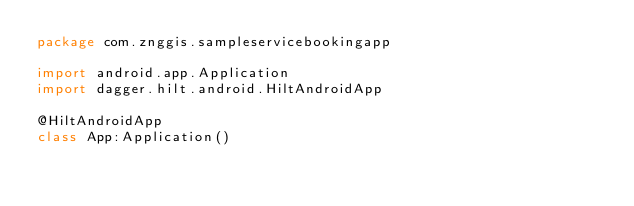Convert code to text. <code><loc_0><loc_0><loc_500><loc_500><_Kotlin_>package com.znggis.sampleservicebookingapp

import android.app.Application
import dagger.hilt.android.HiltAndroidApp

@HiltAndroidApp
class App:Application()</code> 